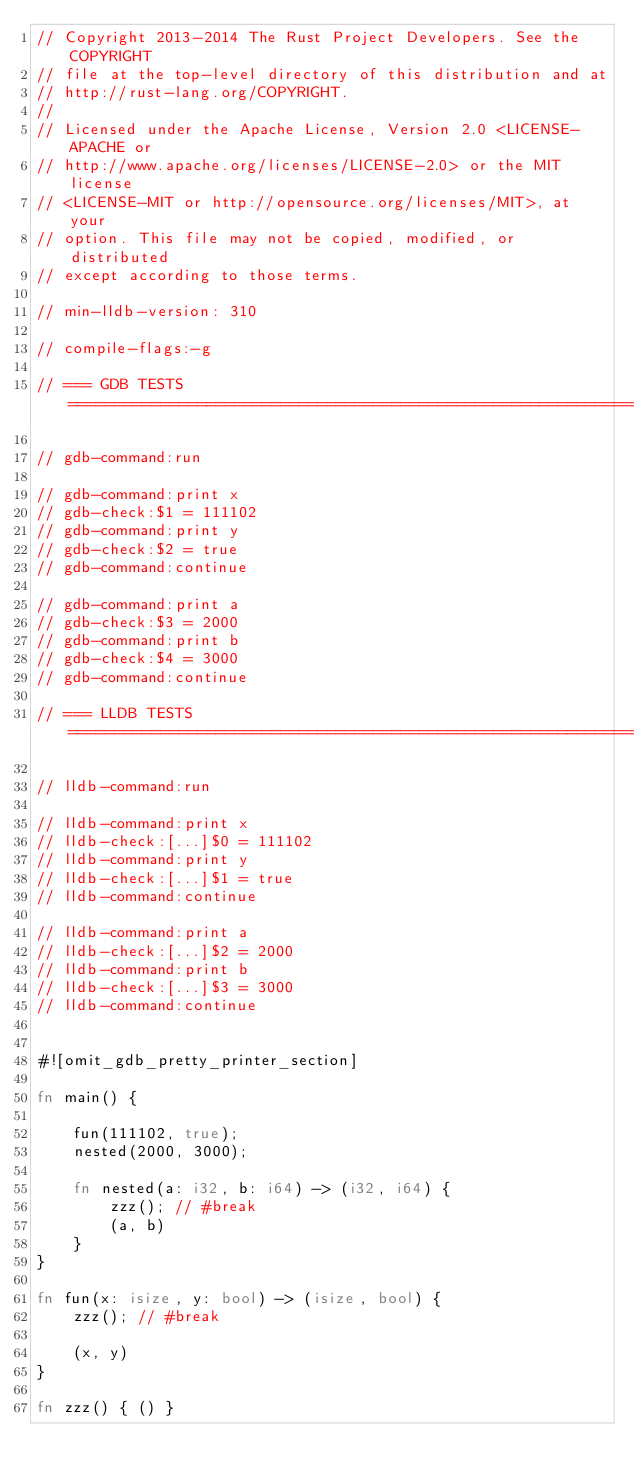Convert code to text. <code><loc_0><loc_0><loc_500><loc_500><_Rust_>// Copyright 2013-2014 The Rust Project Developers. See the COPYRIGHT
// file at the top-level directory of this distribution and at
// http://rust-lang.org/COPYRIGHT.
//
// Licensed under the Apache License, Version 2.0 <LICENSE-APACHE or
// http://www.apache.org/licenses/LICENSE-2.0> or the MIT license
// <LICENSE-MIT or http://opensource.org/licenses/MIT>, at your
// option. This file may not be copied, modified, or distributed
// except according to those terms.

// min-lldb-version: 310

// compile-flags:-g

// === GDB TESTS ===================================================================================

// gdb-command:run

// gdb-command:print x
// gdb-check:$1 = 111102
// gdb-command:print y
// gdb-check:$2 = true
// gdb-command:continue

// gdb-command:print a
// gdb-check:$3 = 2000
// gdb-command:print b
// gdb-check:$4 = 3000
// gdb-command:continue

// === LLDB TESTS ==================================================================================

// lldb-command:run

// lldb-command:print x
// lldb-check:[...]$0 = 111102
// lldb-command:print y
// lldb-check:[...]$1 = true
// lldb-command:continue

// lldb-command:print a
// lldb-check:[...]$2 = 2000
// lldb-command:print b
// lldb-check:[...]$3 = 3000
// lldb-command:continue


#![omit_gdb_pretty_printer_section]

fn main() {

    fun(111102, true);
    nested(2000, 3000);

    fn nested(a: i32, b: i64) -> (i32, i64) {
        zzz(); // #break
        (a, b)
    }
}

fn fun(x: isize, y: bool) -> (isize, bool) {
    zzz(); // #break

    (x, y)
}

fn zzz() { () }
</code> 